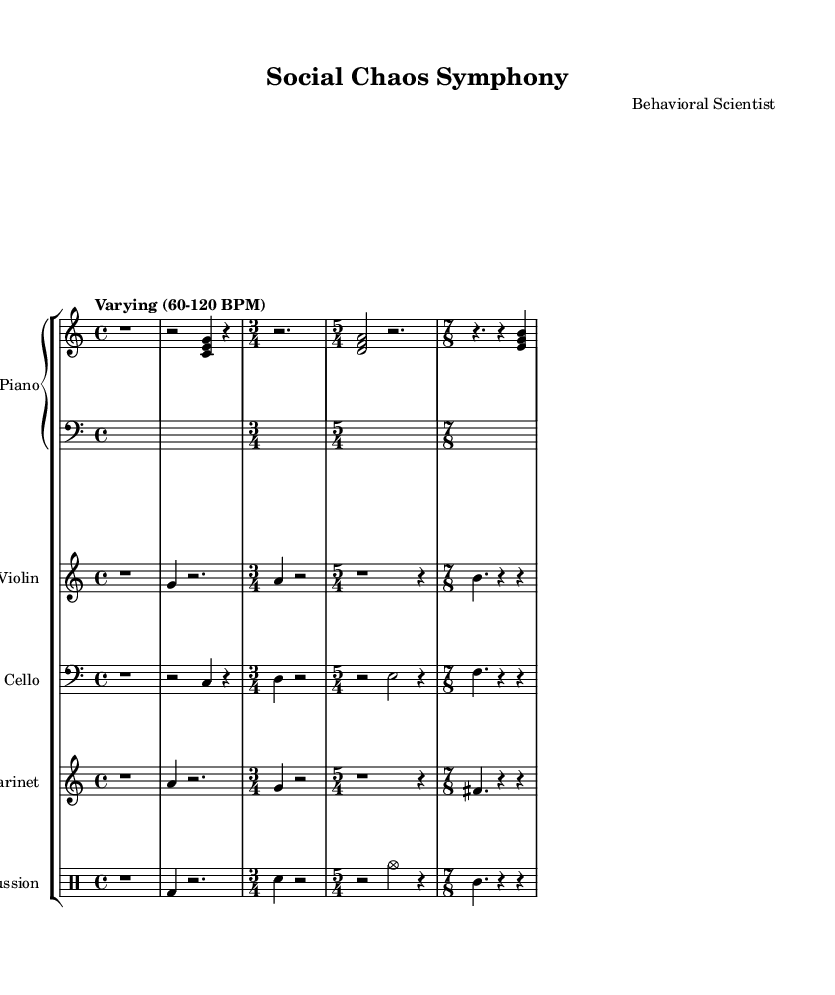What is the key signature of this music? The key signature indicated in the music is C major, which contains no sharps or flats. This can be inferred directly from the first few measures where the absence of accidentals indicates a C major tonality.
Answer: C major What is the time signature used in the first measure? The first measure has a time signature of 4/4, as indicated at the beginning of the score. This is a common time signature, represented clearly at the start of the piece.
Answer: 4/4 How many different time signatures are used in this composition? The composition exhibits four different time signatures: 4/4, 3/4, 5/4, and 7/8. Each of these is explicitly stated in respective sections of the music, requiring observation of the changes throughout the score.
Answer: Four What is the tempo marking for the entire piece? The tempo marking is indicated as "Varying (60-120 BPM)," which suggests that the piece is meant to change speeds within this range. It can be deduced from the remark placed in the global settings at the top of the score.
Answer: Varying (60-120 BPM) Which instrument has the clef marked as "bass"? The cello part is written with the bass clef. This can be easily identified as it is placed at the beginning of the cello staff, which defines the pitches for that instrument.
Answer: Cello How does the structure of atonal compositions affect human behavior? This question invites deeper thought beyond the score’s details; however, atonal compositions often mirror the unpredictabilities of human behavior, paralleling the chaotic nature of social environments, which can create intense emotional responses in listeners.
Answer: Atonal compositions What is the purpose of using multiple time signatures in experimental music? The use of multiple time signatures in experimental music can enhance complexity and reflect the chaotic nature of human behavior across different social environments, offering varied rhythmic experiences to engage listeners more profoundly.
Answer: To enhance complexity 